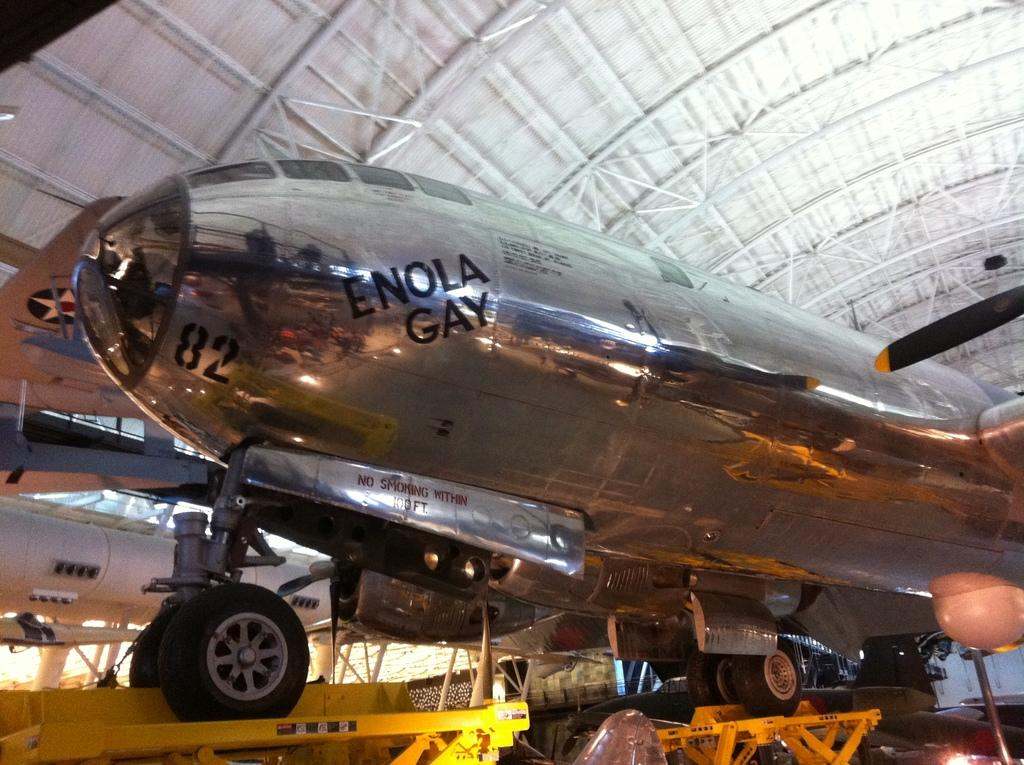What type of vehicle is in the image? There is an airplane with wheels in the image. How is the airplane positioned? The airplane is placed on stands. What can be seen in the background of the image? There are other planes, a metal tube, poles, a shed, and some lights visible in the background. How many eyes can be seen on the airplane in the image? There are no eyes visible on the airplane in the image, as airplanes do not have eyes. 